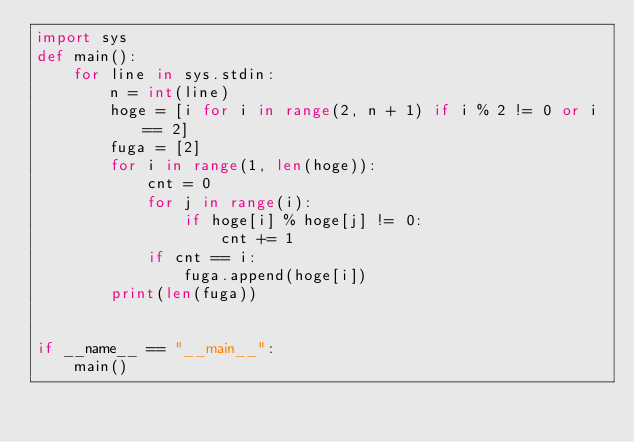Convert code to text. <code><loc_0><loc_0><loc_500><loc_500><_Python_>import sys
def main():
    for line in sys.stdin:
        n = int(line)
        hoge = [i for i in range(2, n + 1) if i % 2 != 0 or i == 2]
        fuga = [2]
        for i in range(1, len(hoge)):
            cnt = 0
            for j in range(i):
                if hoge[i] % hoge[j] != 0:
                    cnt += 1
            if cnt == i:
                fuga.append(hoge[i])
        print(len(fuga))


if __name__ == "__main__":
    main()</code> 